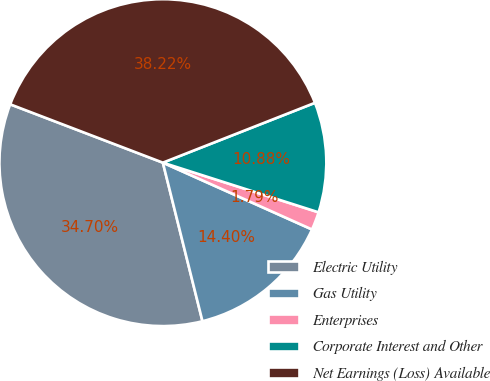Convert chart to OTSL. <chart><loc_0><loc_0><loc_500><loc_500><pie_chart><fcel>Electric Utility<fcel>Gas Utility<fcel>Enterprises<fcel>Corporate Interest and Other<fcel>Net Earnings (Loss) Available<nl><fcel>34.7%<fcel>14.4%<fcel>1.79%<fcel>10.88%<fcel>38.22%<nl></chart> 